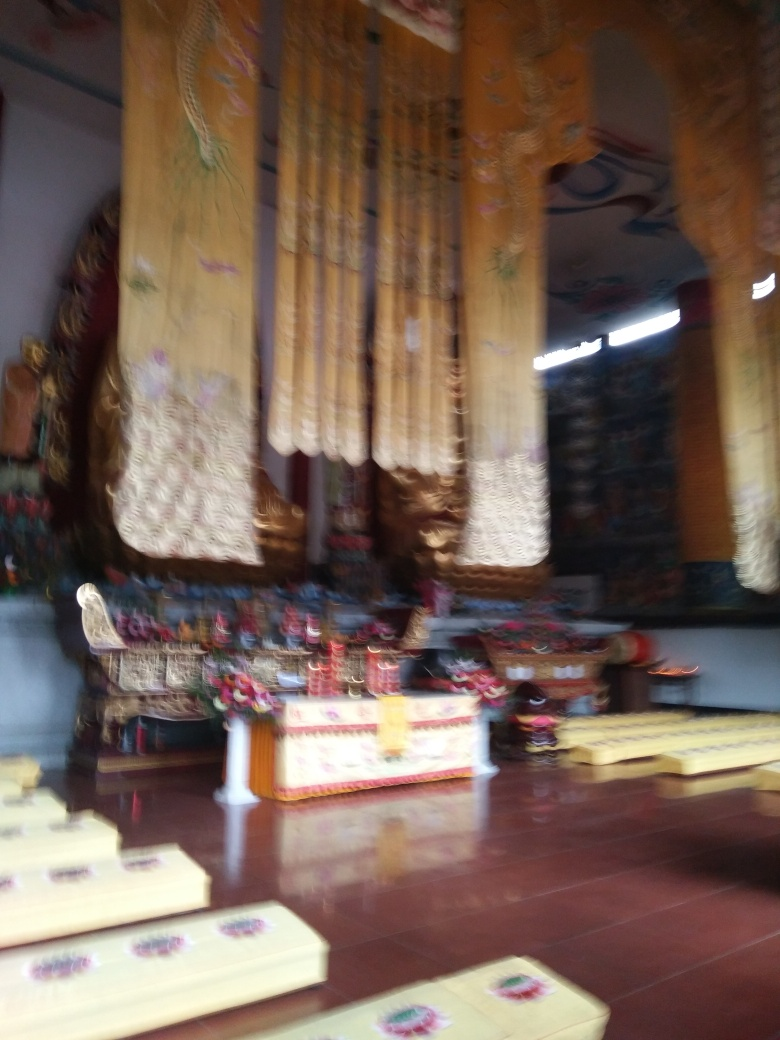What might be the occasion for such decorations and seating arrangement? Given the decor and the setting, it could be for a religious ceremony or a festive event. The decorations suggest a significant celebration or ritual that is observed with reverence and involves community participation. 